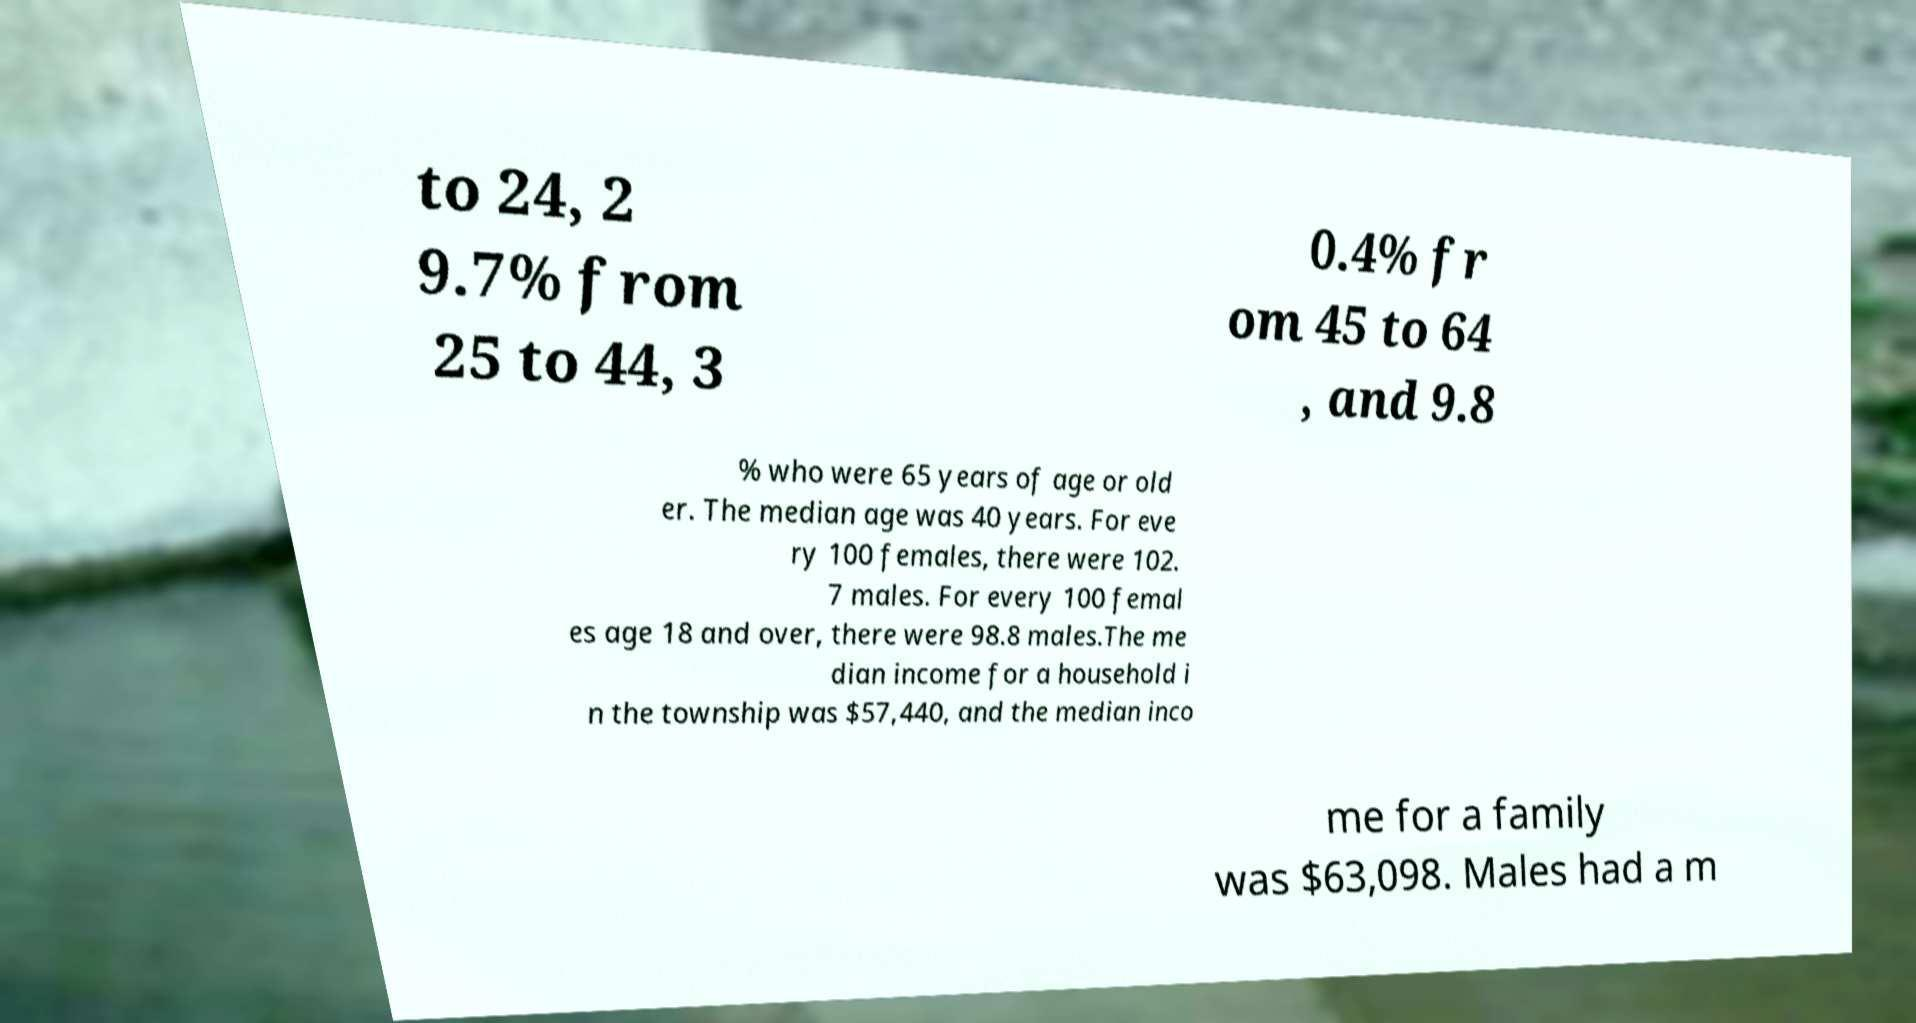Could you assist in decoding the text presented in this image and type it out clearly? to 24, 2 9.7% from 25 to 44, 3 0.4% fr om 45 to 64 , and 9.8 % who were 65 years of age or old er. The median age was 40 years. For eve ry 100 females, there were 102. 7 males. For every 100 femal es age 18 and over, there were 98.8 males.The me dian income for a household i n the township was $57,440, and the median inco me for a family was $63,098. Males had a m 